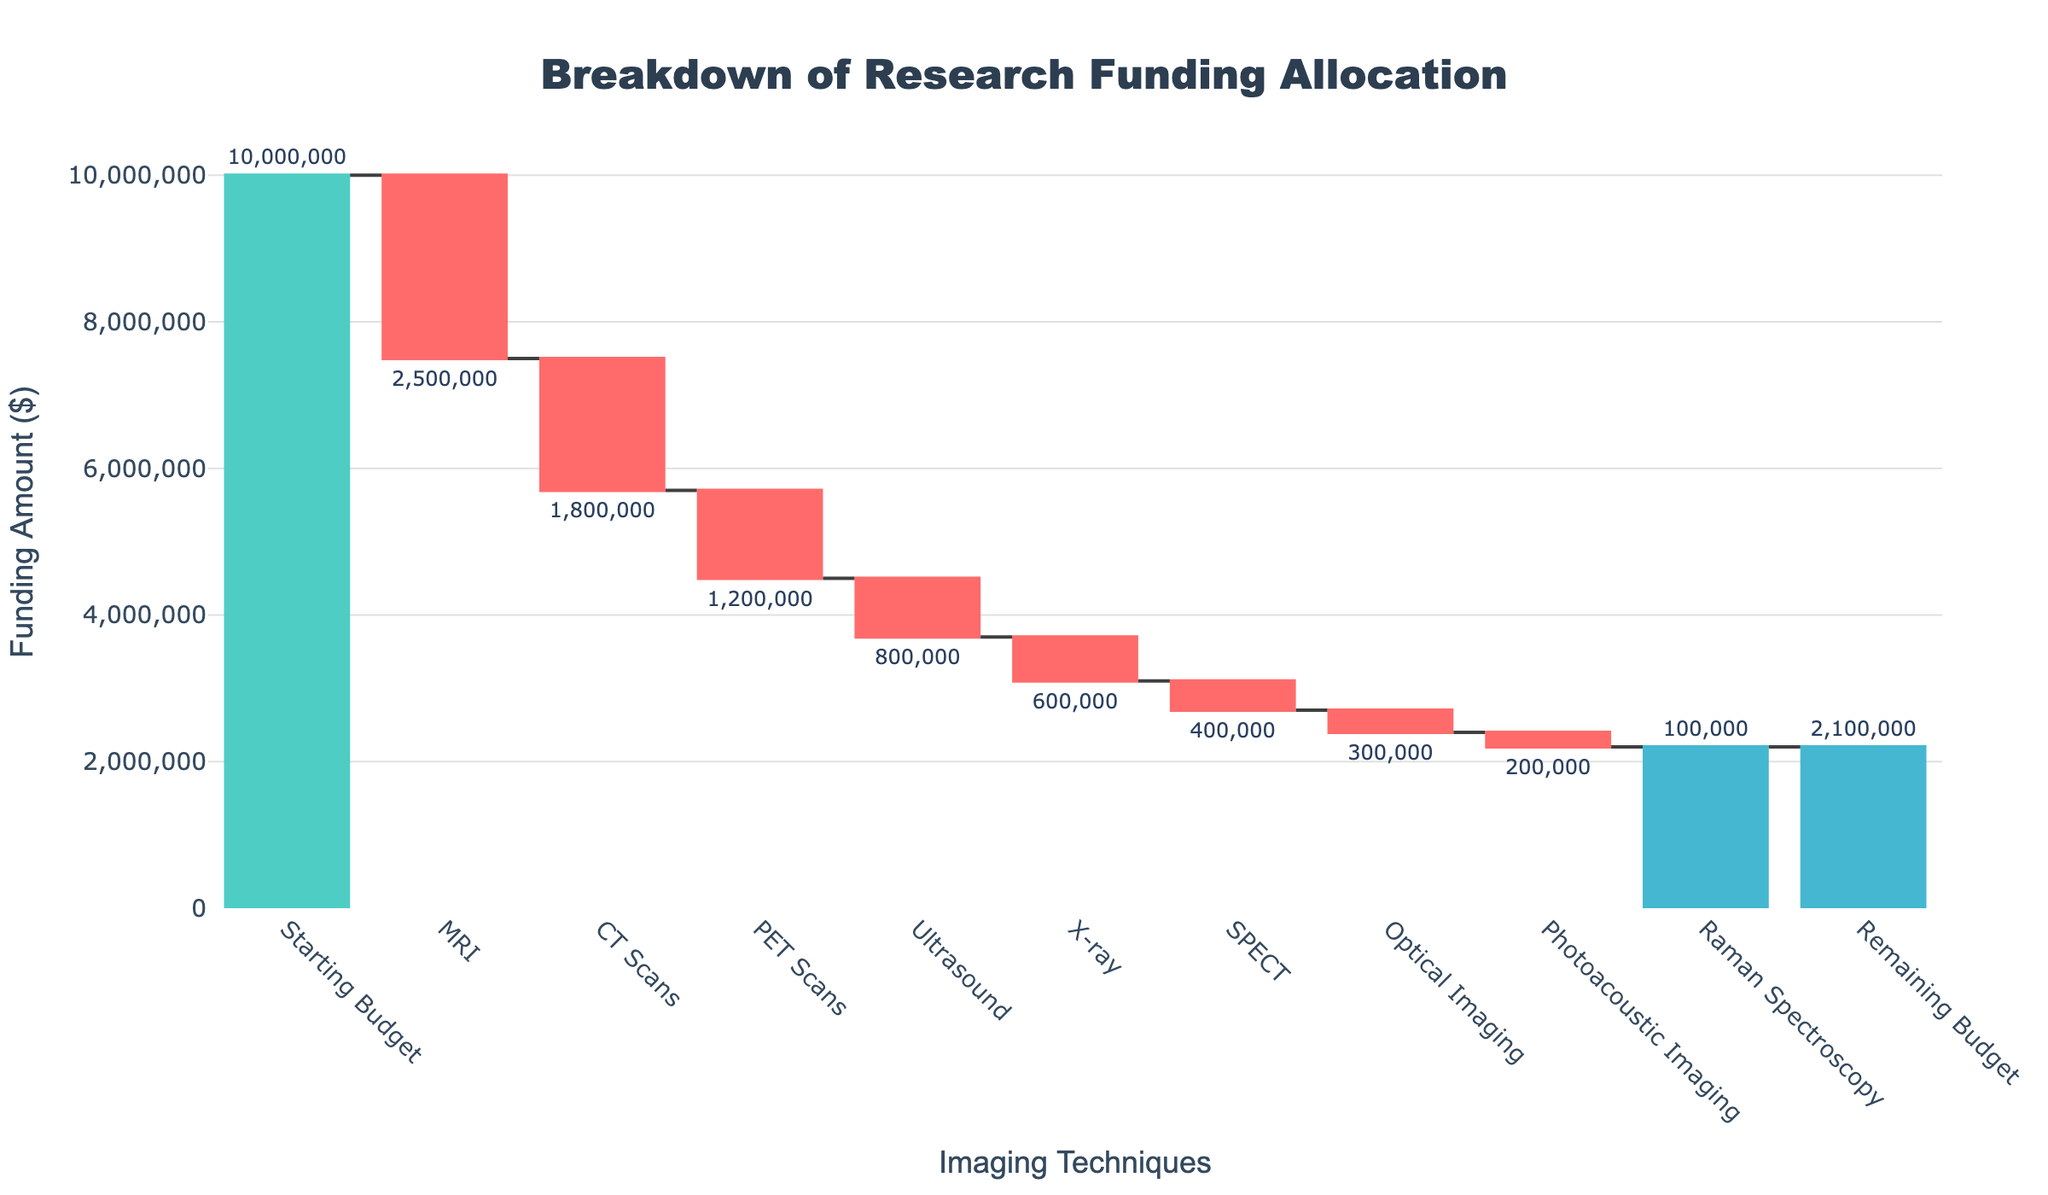How much total funding was allocated to MRI? The waterfall chart shows the individual allocations for each category. The MRI category has an allocation of -$2,500,000
Answer: $2,500,000 What is the remaining budget after all allocations? The last bar represents the remaining budget after all other categories' allocations. It is labeled as 2,100,000
Answer: $2,100,000 Which imaging technique received the smallest amount of funding? By comparing the negative values of the allocations for each technique, the Raman Spectroscopy category has the smallest absolute value of $100,000
Answer: Raman Spectroscopy How much funding is allocated to CT Scans and Ultrasound combined? To find the combined allocation, sum the absolute values of the funding for CT Scans and Ultrasound: $1,800,000 + $800,000 = $2,600,000
Answer: $2,600,000 Which technique received more funding, PET Scans or X-ray? By comparing the absolute values of the funding allocations for PET Scans and X-ray, PET Scans received $1,200,000 while X-ray received $600,000
Answer: PET Scans By what amount did the starting budget decrease due to the funding allocated to MRI? The allocation for MRI is -$2,500,000, which means the starting budget decreased by $2,500,000
Answer: $2,500,000 What is the total funding allocated to Optical Imaging and Photoacoustic Imaging? The allocations for Optical Imaging and Photoacoustic Imaging are -$300,000 and -$200,000 respectively. Combined, these are $300,000 + $200,000 = $500,000
Answer: $500,000 Arrange the imaging techniques MRI, CT Scans, and PET Scans in order of funding received (highest to lowest). The funding received by each is as follows: MRI = $2,500,000, CT Scans = $1,800,000, PET Scans = $1,200,000. Arranged in descending order, it is MRI, CT Scans, PET Scans
Answer: MRI, CT Scans, PET Scans How much more funding did SPECT receive compared to Raman Spectroscopy? The allocation for SPECT is -$400,000 and for Raman Spectroscopy is -$100,000. The difference is $400,000 - $100,000 = $300,000
Answer: $300,000 